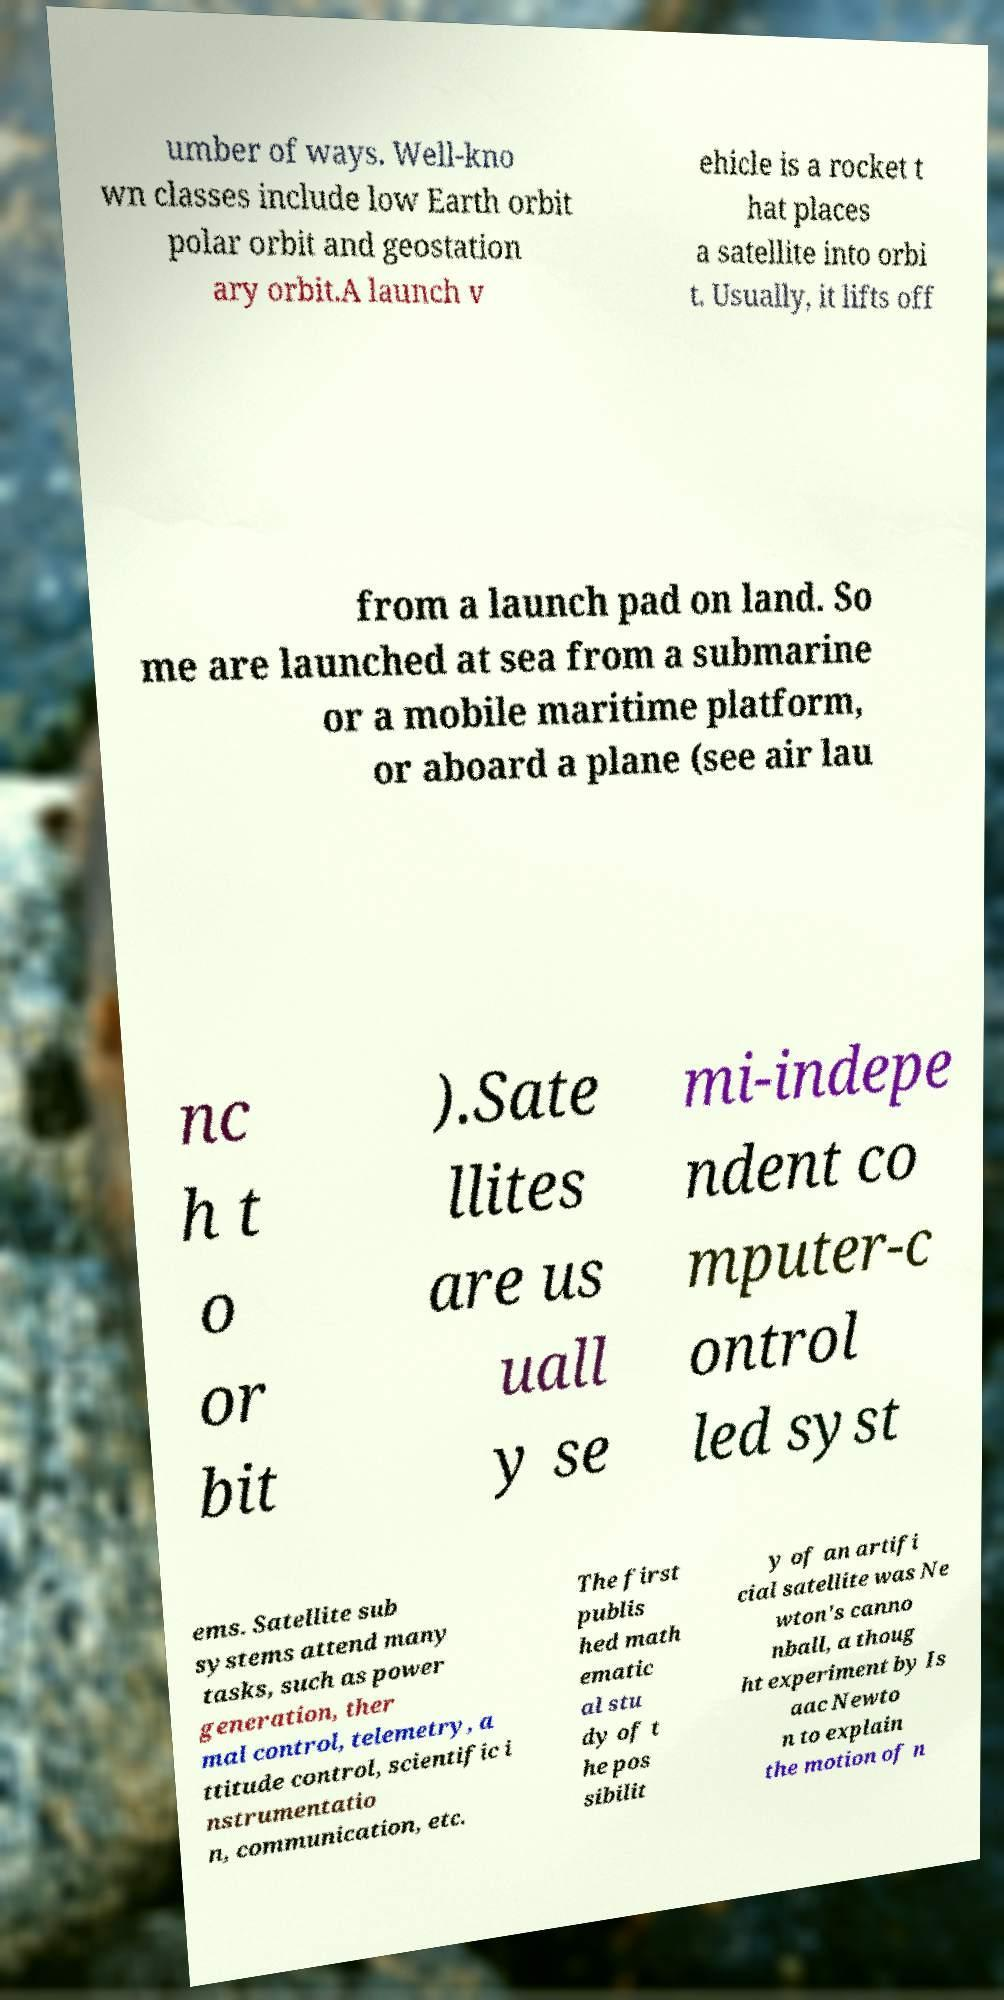I need the written content from this picture converted into text. Can you do that? umber of ways. Well-kno wn classes include low Earth orbit polar orbit and geostation ary orbit.A launch v ehicle is a rocket t hat places a satellite into orbi t. Usually, it lifts off from a launch pad on land. So me are launched at sea from a submarine or a mobile maritime platform, or aboard a plane (see air lau nc h t o or bit ).Sate llites are us uall y se mi-indepe ndent co mputer-c ontrol led syst ems. Satellite sub systems attend many tasks, such as power generation, ther mal control, telemetry, a ttitude control, scientific i nstrumentatio n, communication, etc. The first publis hed math ematic al stu dy of t he pos sibilit y of an artifi cial satellite was Ne wton's canno nball, a thoug ht experiment by Is aac Newto n to explain the motion of n 